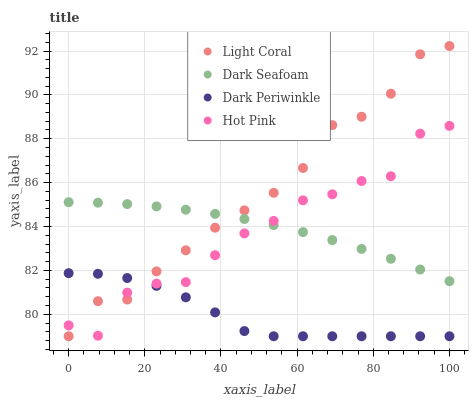Does Dark Periwinkle have the minimum area under the curve?
Answer yes or no. Yes. Does Light Coral have the maximum area under the curve?
Answer yes or no. Yes. Does Dark Seafoam have the minimum area under the curve?
Answer yes or no. No. Does Dark Seafoam have the maximum area under the curve?
Answer yes or no. No. Is Dark Seafoam the smoothest?
Answer yes or no. Yes. Is Hot Pink the roughest?
Answer yes or no. Yes. Is Hot Pink the smoothest?
Answer yes or no. No. Is Dark Seafoam the roughest?
Answer yes or no. No. Does Light Coral have the lowest value?
Answer yes or no. Yes. Does Hot Pink have the lowest value?
Answer yes or no. No. Does Light Coral have the highest value?
Answer yes or no. Yes. Does Dark Seafoam have the highest value?
Answer yes or no. No. Is Dark Periwinkle less than Dark Seafoam?
Answer yes or no. Yes. Is Dark Seafoam greater than Dark Periwinkle?
Answer yes or no. Yes. Does Light Coral intersect Hot Pink?
Answer yes or no. Yes. Is Light Coral less than Hot Pink?
Answer yes or no. No. Is Light Coral greater than Hot Pink?
Answer yes or no. No. Does Dark Periwinkle intersect Dark Seafoam?
Answer yes or no. No. 